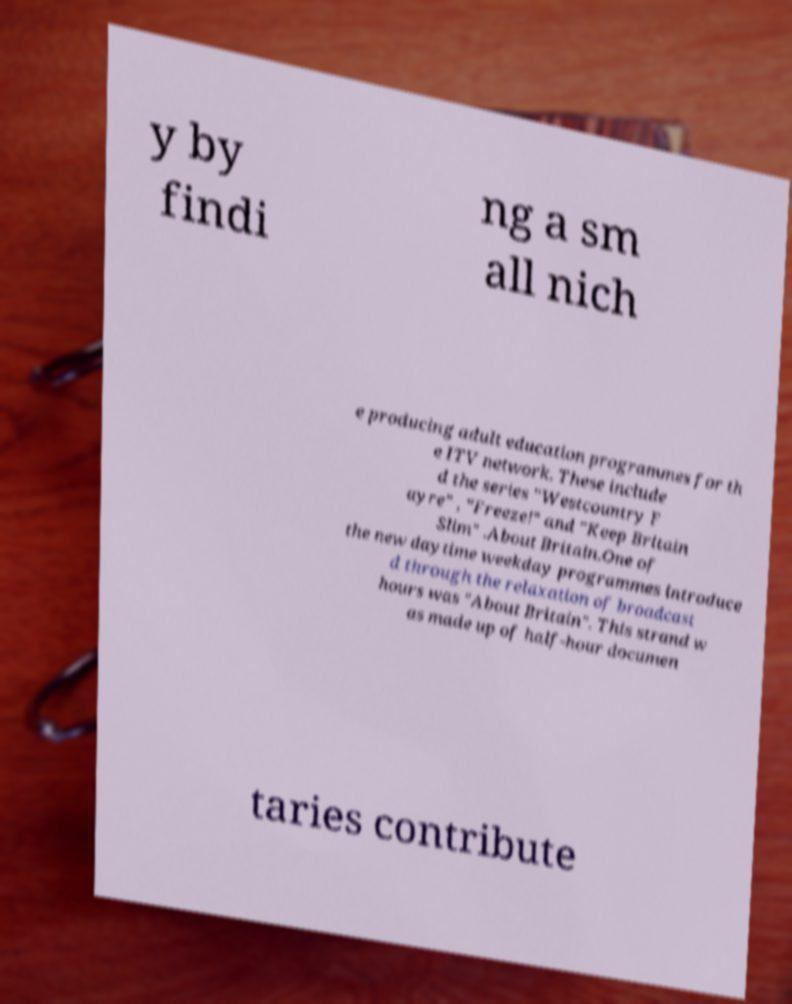Please identify and transcribe the text found in this image. y by findi ng a sm all nich e producing adult education programmes for th e ITV network. These include d the series "Westcountry F ayre" , "Freeze!" and "Keep Britain Slim" .About Britain.One of the new daytime weekday programmes introduce d through the relaxation of broadcast hours was "About Britain". This strand w as made up of half-hour documen taries contribute 